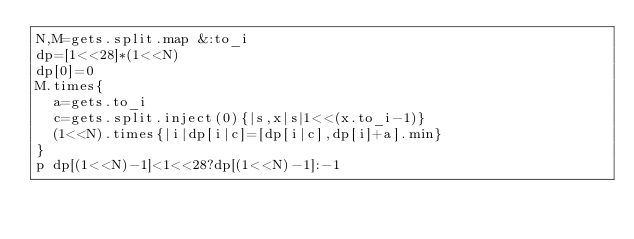<code> <loc_0><loc_0><loc_500><loc_500><_Ruby_>N,M=gets.split.map &:to_i
dp=[1<<28]*(1<<N)
dp[0]=0
M.times{
	a=gets.to_i
	c=gets.split.inject(0){|s,x|s|1<<(x.to_i-1)}
	(1<<N).times{|i|dp[i|c]=[dp[i|c],dp[i]+a].min}
}
p dp[(1<<N)-1]<1<<28?dp[(1<<N)-1]:-1</code> 